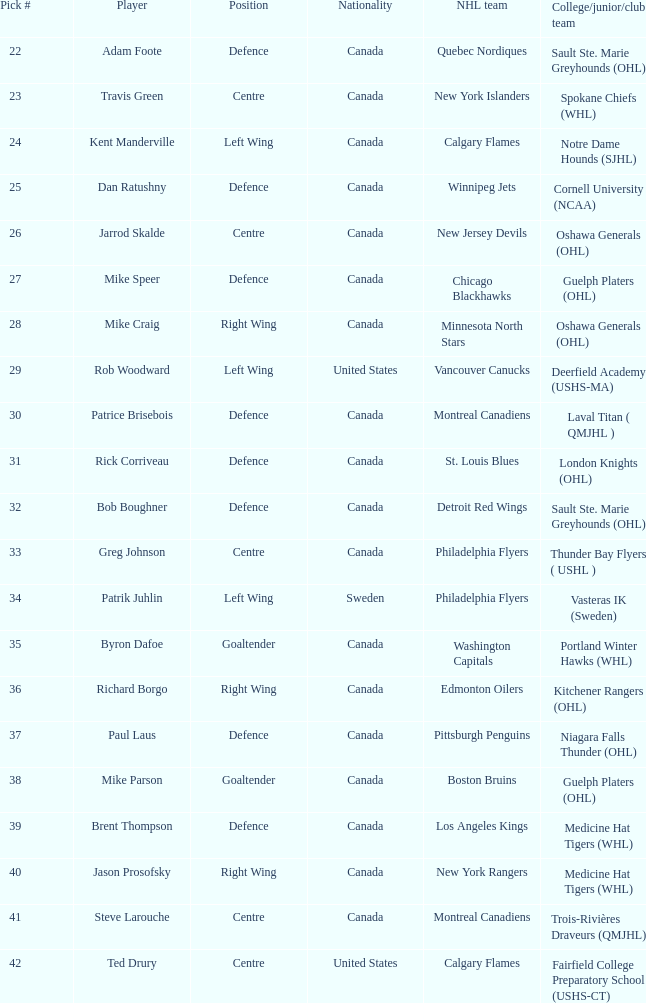What is the country of origin for the player chosen to join the washington capitals? Canada. 